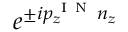Convert formula to latex. <formula><loc_0><loc_0><loc_500><loc_500>e ^ { \pm i p _ { z } ^ { I N } n _ { z } }</formula> 